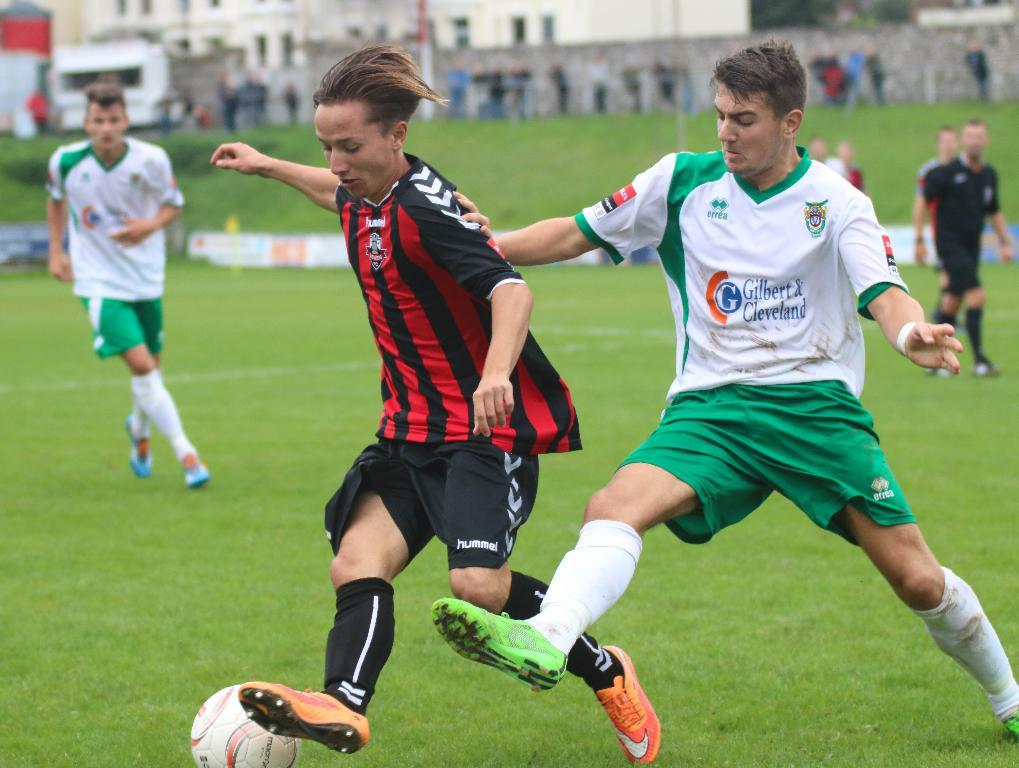What activity are the people in the image engaged in? The people in the image are playing football. Where is the football game taking place? The football game is taking place on a green field. What can be seen in the background of the image? There are buildings visible in the image. What type of land is visible in the image? There is no specific type of land mentioned or visible in the image; it only shows a football game taking place on a green field. What place does the football game represent in the image? The image does not represent a specific place; it simply shows a football game taking place on a green field. --- 